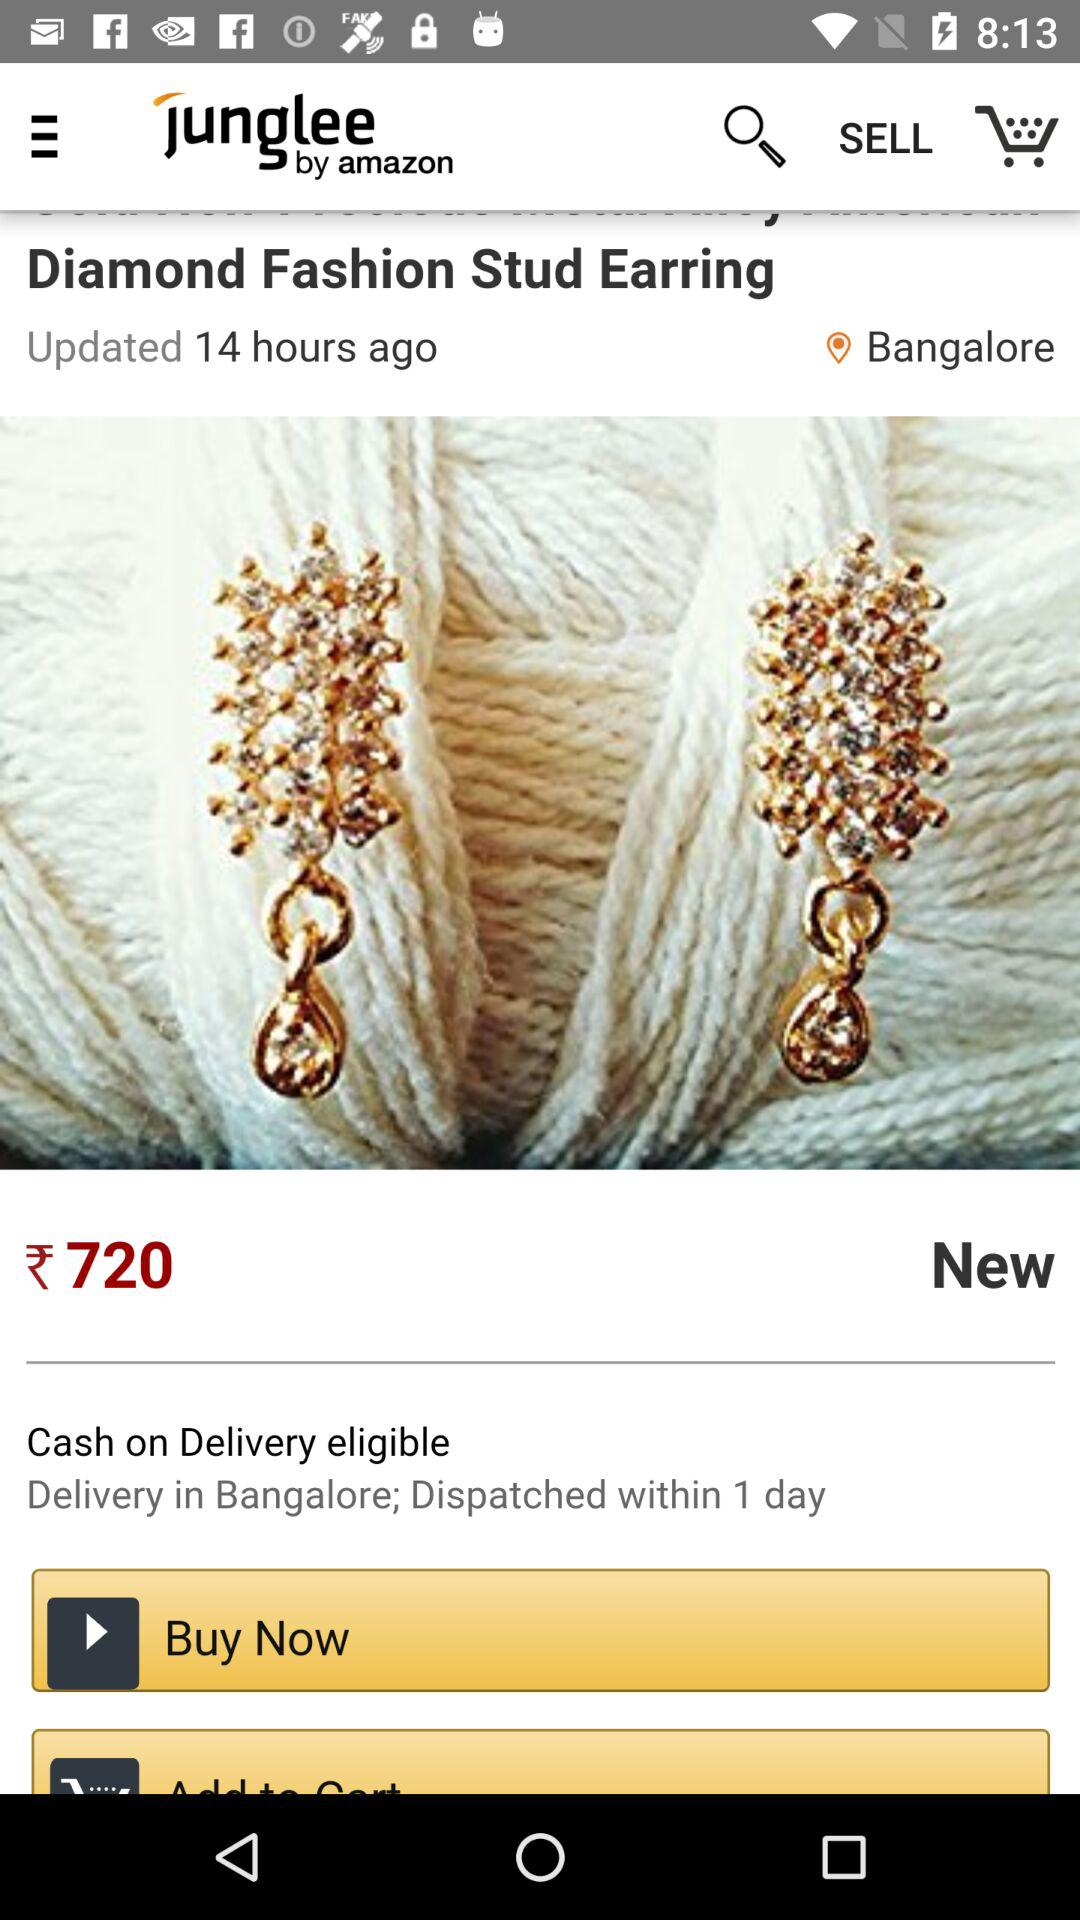What is the name of the product? The name of the product is "Diamond Fashion Stud Earring". 